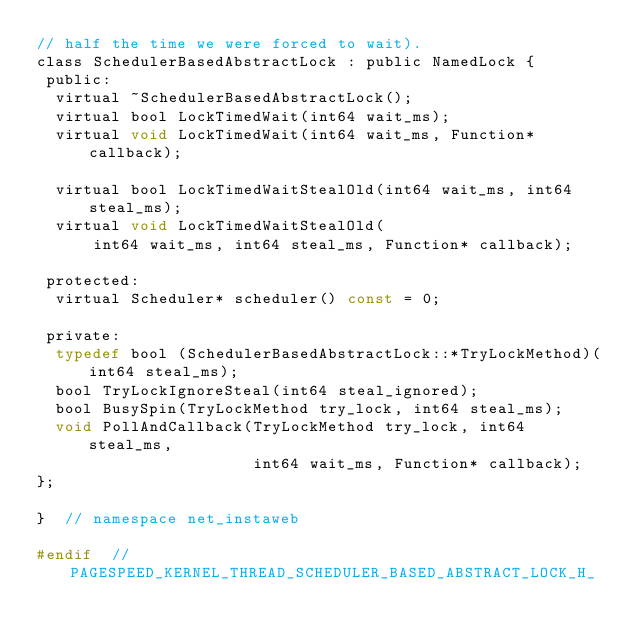<code> <loc_0><loc_0><loc_500><loc_500><_C_>// half the time we were forced to wait).
class SchedulerBasedAbstractLock : public NamedLock {
 public:
  virtual ~SchedulerBasedAbstractLock();
  virtual bool LockTimedWait(int64 wait_ms);
  virtual void LockTimedWait(int64 wait_ms, Function* callback);

  virtual bool LockTimedWaitStealOld(int64 wait_ms, int64 steal_ms);
  virtual void LockTimedWaitStealOld(
      int64 wait_ms, int64 steal_ms, Function* callback);

 protected:
  virtual Scheduler* scheduler() const = 0;

 private:
  typedef bool (SchedulerBasedAbstractLock::*TryLockMethod)(int64 steal_ms);
  bool TryLockIgnoreSteal(int64 steal_ignored);
  bool BusySpin(TryLockMethod try_lock, int64 steal_ms);
  void PollAndCallback(TryLockMethod try_lock, int64 steal_ms,
                       int64 wait_ms, Function* callback);
};

}  // namespace net_instaweb

#endif  // PAGESPEED_KERNEL_THREAD_SCHEDULER_BASED_ABSTRACT_LOCK_H_
</code> 